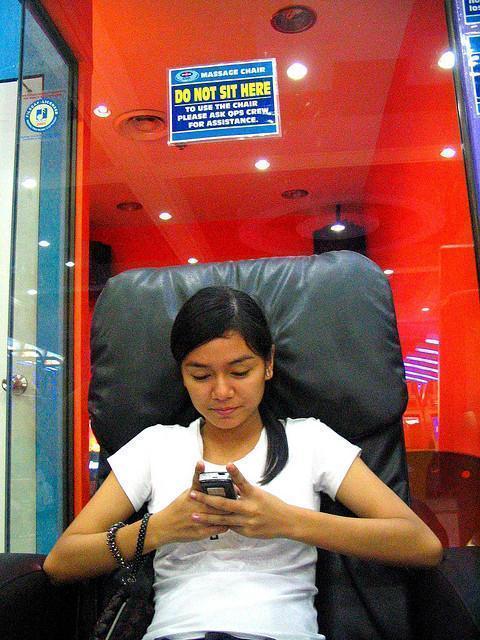What service is this lady receiving?
From the following four choices, select the correct answer to address the question.
Options: Nail treatment, haircut, massage, facial treatment. Massage. 